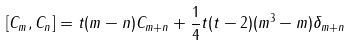Convert formula to latex. <formula><loc_0><loc_0><loc_500><loc_500>[ C _ { m } , C _ { n } ] = t ( m - n ) C _ { m + n } + \frac { 1 } { 4 } t ( t - 2 ) ( m ^ { 3 } - m ) \delta _ { m + n }</formula> 